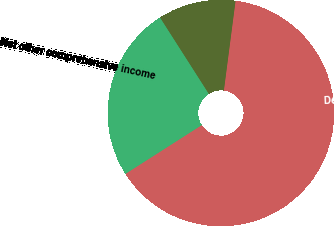<chart> <loc_0><loc_0><loc_500><loc_500><pie_chart><fcel>December 31 2012<fcel>Other comprehensive income<fcel>Net other comprehensive income<fcel>December 31 2013<nl><fcel>44.44%<fcel>11.11%<fcel>25.0%<fcel>19.44%<nl></chart> 